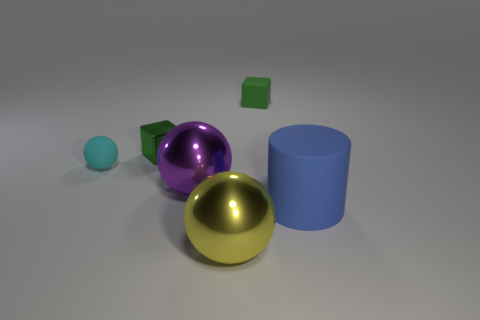What number of other things are there of the same color as the small metal thing?
Offer a very short reply. 1. There is a matte cylinder in front of the tiny rubber object that is left of the large purple metallic sphere; how many purple things are behind it?
Your answer should be very brief. 1. Is the size of the shiny ball in front of the purple shiny sphere the same as the metal sphere that is behind the big blue rubber cylinder?
Ensure brevity in your answer.  Yes. What is the material of the small thing that is the same shape as the large yellow metallic thing?
Your answer should be very brief. Rubber. What number of small objects are blue matte cylinders or purple shiny things?
Your answer should be compact. 0. What material is the cyan object?
Ensure brevity in your answer.  Rubber. There is a thing that is behind the cyan matte thing and on the right side of the big yellow metallic ball; what material is it made of?
Offer a terse response. Rubber. Does the tiny metallic cube have the same color as the tiny matte object behind the tiny cyan ball?
Make the answer very short. Yes. What is the material of the purple object that is the same size as the rubber cylinder?
Keep it short and to the point. Metal. Is there another tiny yellow ball that has the same material as the yellow ball?
Offer a very short reply. No. 